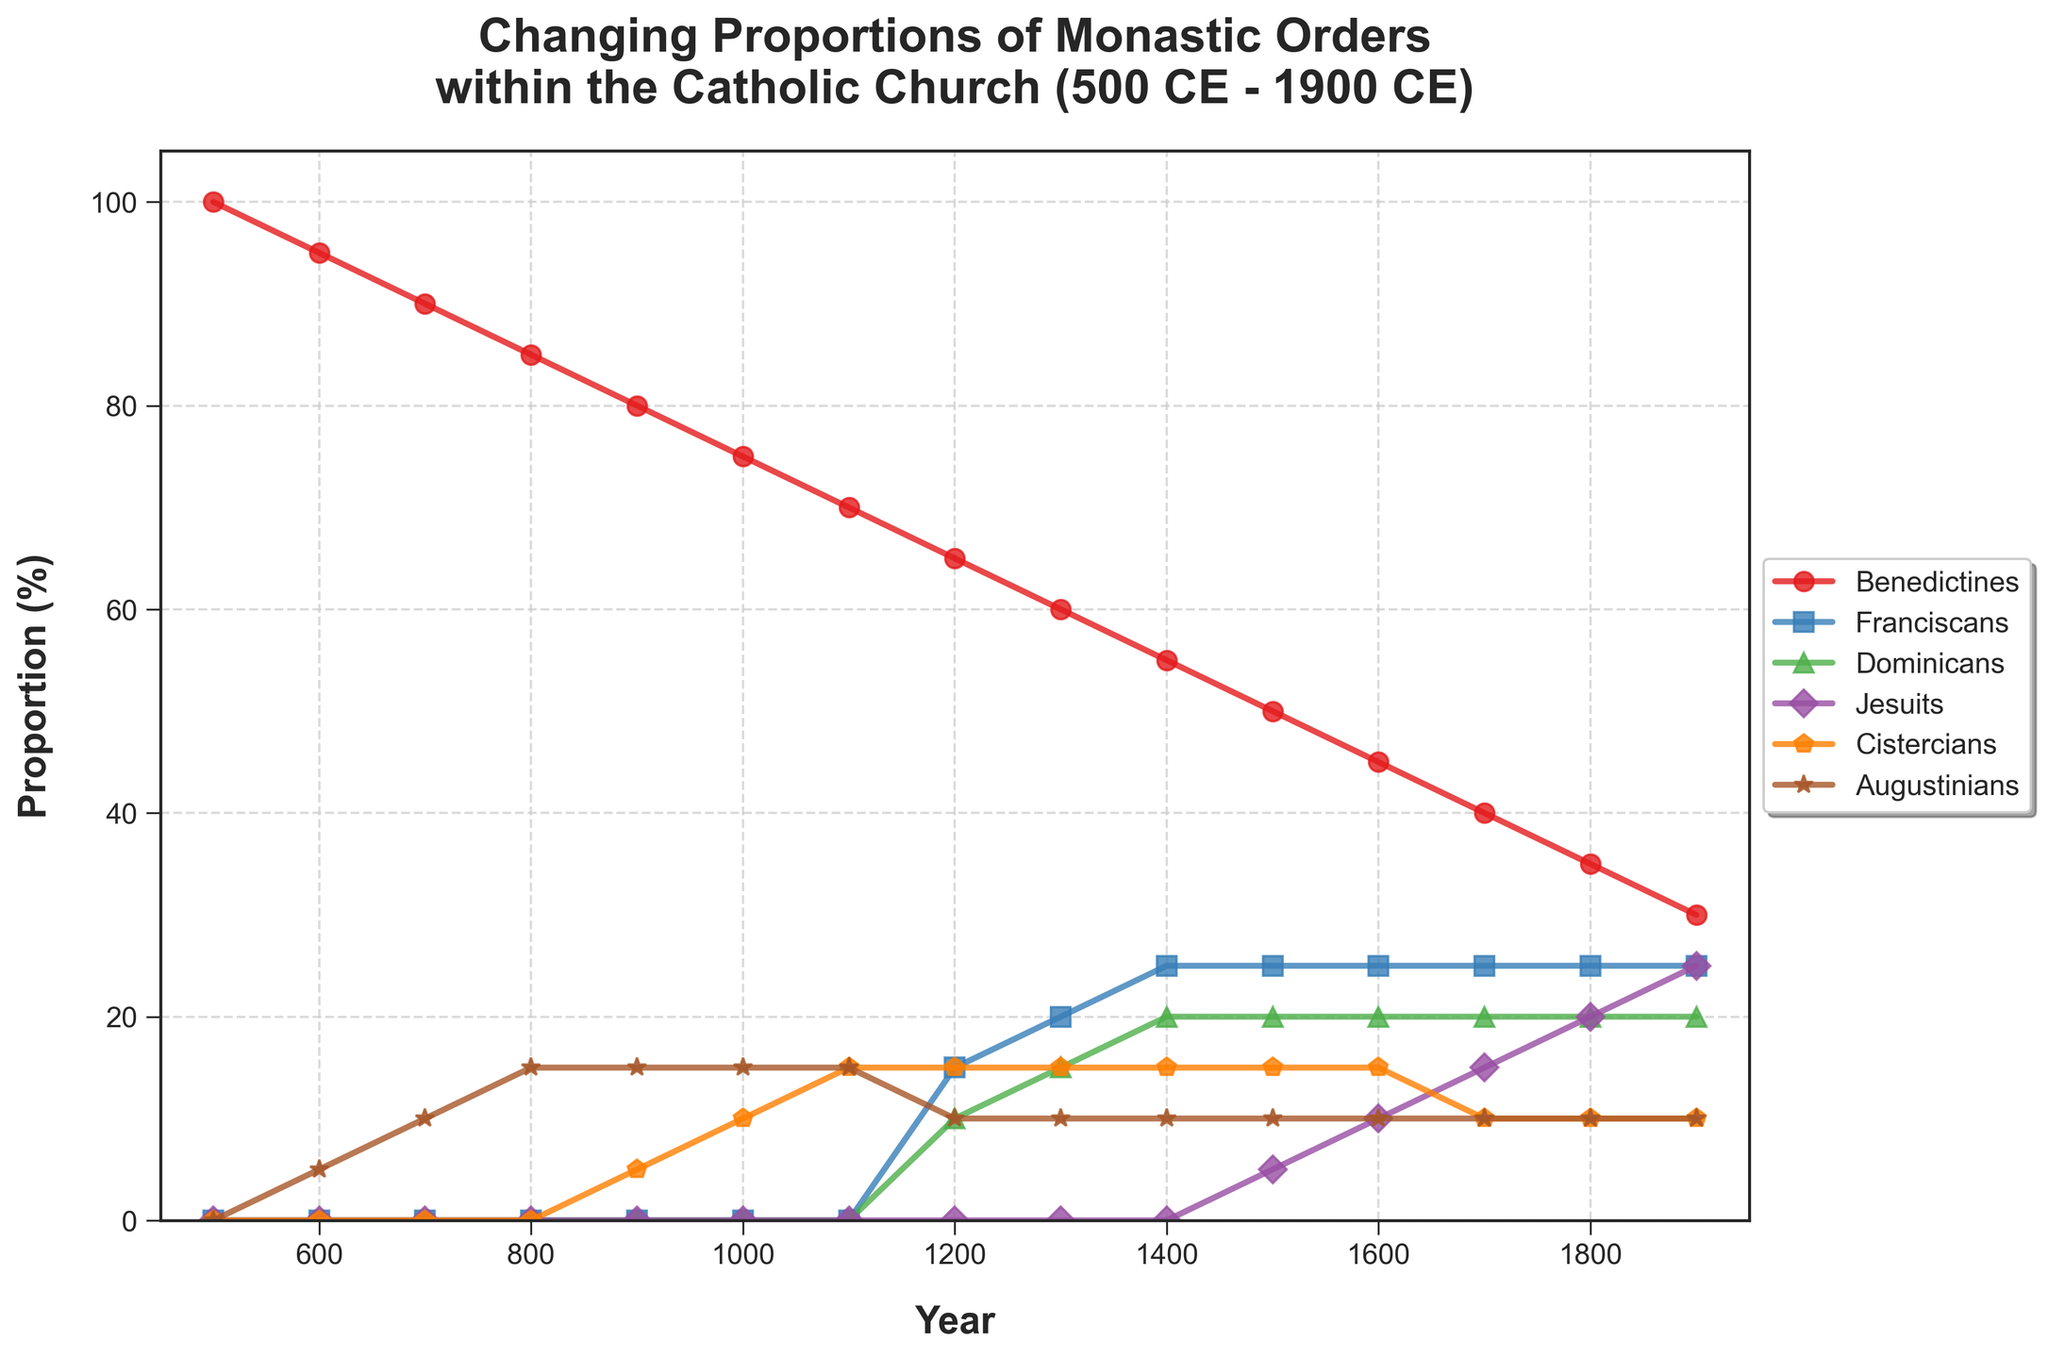How did the proportion of Benedictines change from 500 CE to 900 CE? The proportion of Benedictines decreased from 100% in 500 CE to 80% in 900 CE. To find this, we look at the Benedictines line in the chart, observe the percentages at these two years, and then compare them.
Answer: Decreased by 20% What was the difference in proportions between Franciscans and Dominicans in 1300 CE? In 1300 CE, the proportion of Franciscans was 20% and Dominicans was 15%. Subtracting the proportion of Dominicans from Franciscans gives the difference. 20% - 15% = 5%
Answer: 5% During which century did Jesuits first appear in the chart? Jesuits appear in the chart starting from the year 1500. The line for Jesuits starts at 1500 CE at 5%.
Answer: 16th century Which order had the largest proportion in 1700 CE, and what was that proportion? In 1700 CE, the Benedictines had the largest proportion at 40%. To find this, we observe the chart for the year 1700 and compare the heights of all lines.
Answer: Benedictines, 40% How did the proportions of the Cistercians change from 1000 CE to 1100 CE? The proportion of Cistercians increased from 10% to 15% between 1000 CE and 1100 CE. This is observed by following the line for Cistercians between these two years and noting the change in percentage.
Answer: Increased by 5% What is the total proportion of all monastic orders in 1500 CE? The proportions in 1500 CE are Benedictines: 50%, Franciscans: 25%, Dominicans: 20%, Jesuits: 5%, Cistercians: 15%, Augustinians: 10%. Summing these proportions: 50% + 25% + 20% + 5% + 15% + 10% = 125%.
Answer: 125% Which order shows the most consistent proportion (least change) from 1200 CE to 1900 CE? The Augustinians show the most consistent proportion with a nearly stable line around 10-15% from 1200 CE to 1900 CE. We find this by comparing the fluctuations in proportion lines of all orders during this period.
Answer: Augustinians What two orders had the same proportion in 1900 CE and what was that proportion? In 1900 CE, the Benedictines and the Augustinians both had proportions of 10%. This is visible in the chart where their lines intersect at this year.
Answer: Benedictines and Augustinians, 10% Which monastic order declined the most in proportion from 500 CE to 1900 CE? The Benedictines declined the most, from 100% in 500 CE to 30% in 1900 CE. This is determined by observing the starting and ending proportions of all orders and comparing the differences.
Answer: Benedictines 